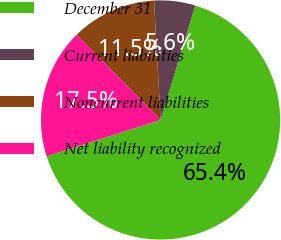Convert chart. <chart><loc_0><loc_0><loc_500><loc_500><pie_chart><fcel>December 31<fcel>Current liabilities<fcel>Noncurrent liabilities<fcel>Net liability recognized<nl><fcel>65.4%<fcel>5.55%<fcel>11.53%<fcel>17.52%<nl></chart> 